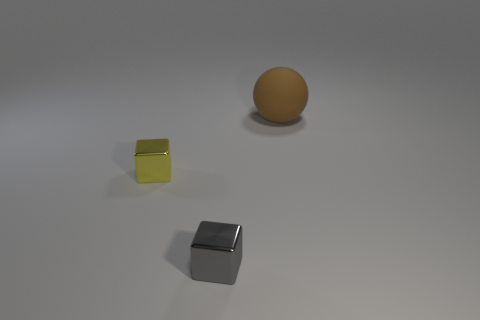Add 2 big rubber spheres. How many objects exist? 5 Subtract all spheres. How many objects are left? 2 Subtract 0 green cylinders. How many objects are left? 3 Subtract all small objects. Subtract all big green metal objects. How many objects are left? 1 Add 2 large spheres. How many large spheres are left? 3 Add 1 big brown matte balls. How many big brown matte balls exist? 2 